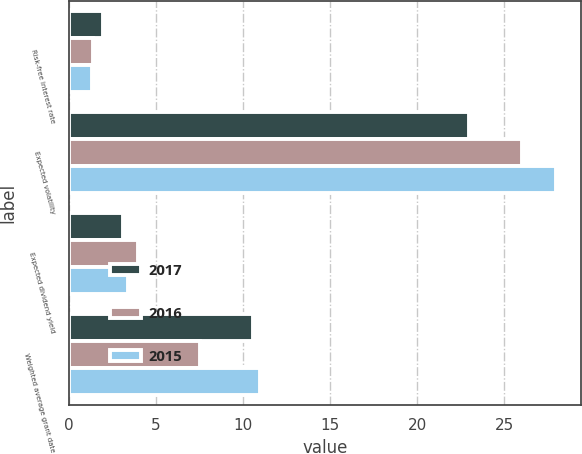<chart> <loc_0><loc_0><loc_500><loc_500><stacked_bar_chart><ecel><fcel>Risk-free interest rate<fcel>Expected volatility<fcel>Expected dividend yield<fcel>Weighted average grant date<nl><fcel>2017<fcel>1.97<fcel>23<fcel>3.1<fcel>10.56<nl><fcel>2016<fcel>1.37<fcel>26<fcel>4<fcel>7.51<nl><fcel>2015<fcel>1.35<fcel>28<fcel>3.4<fcel>10.98<nl></chart> 